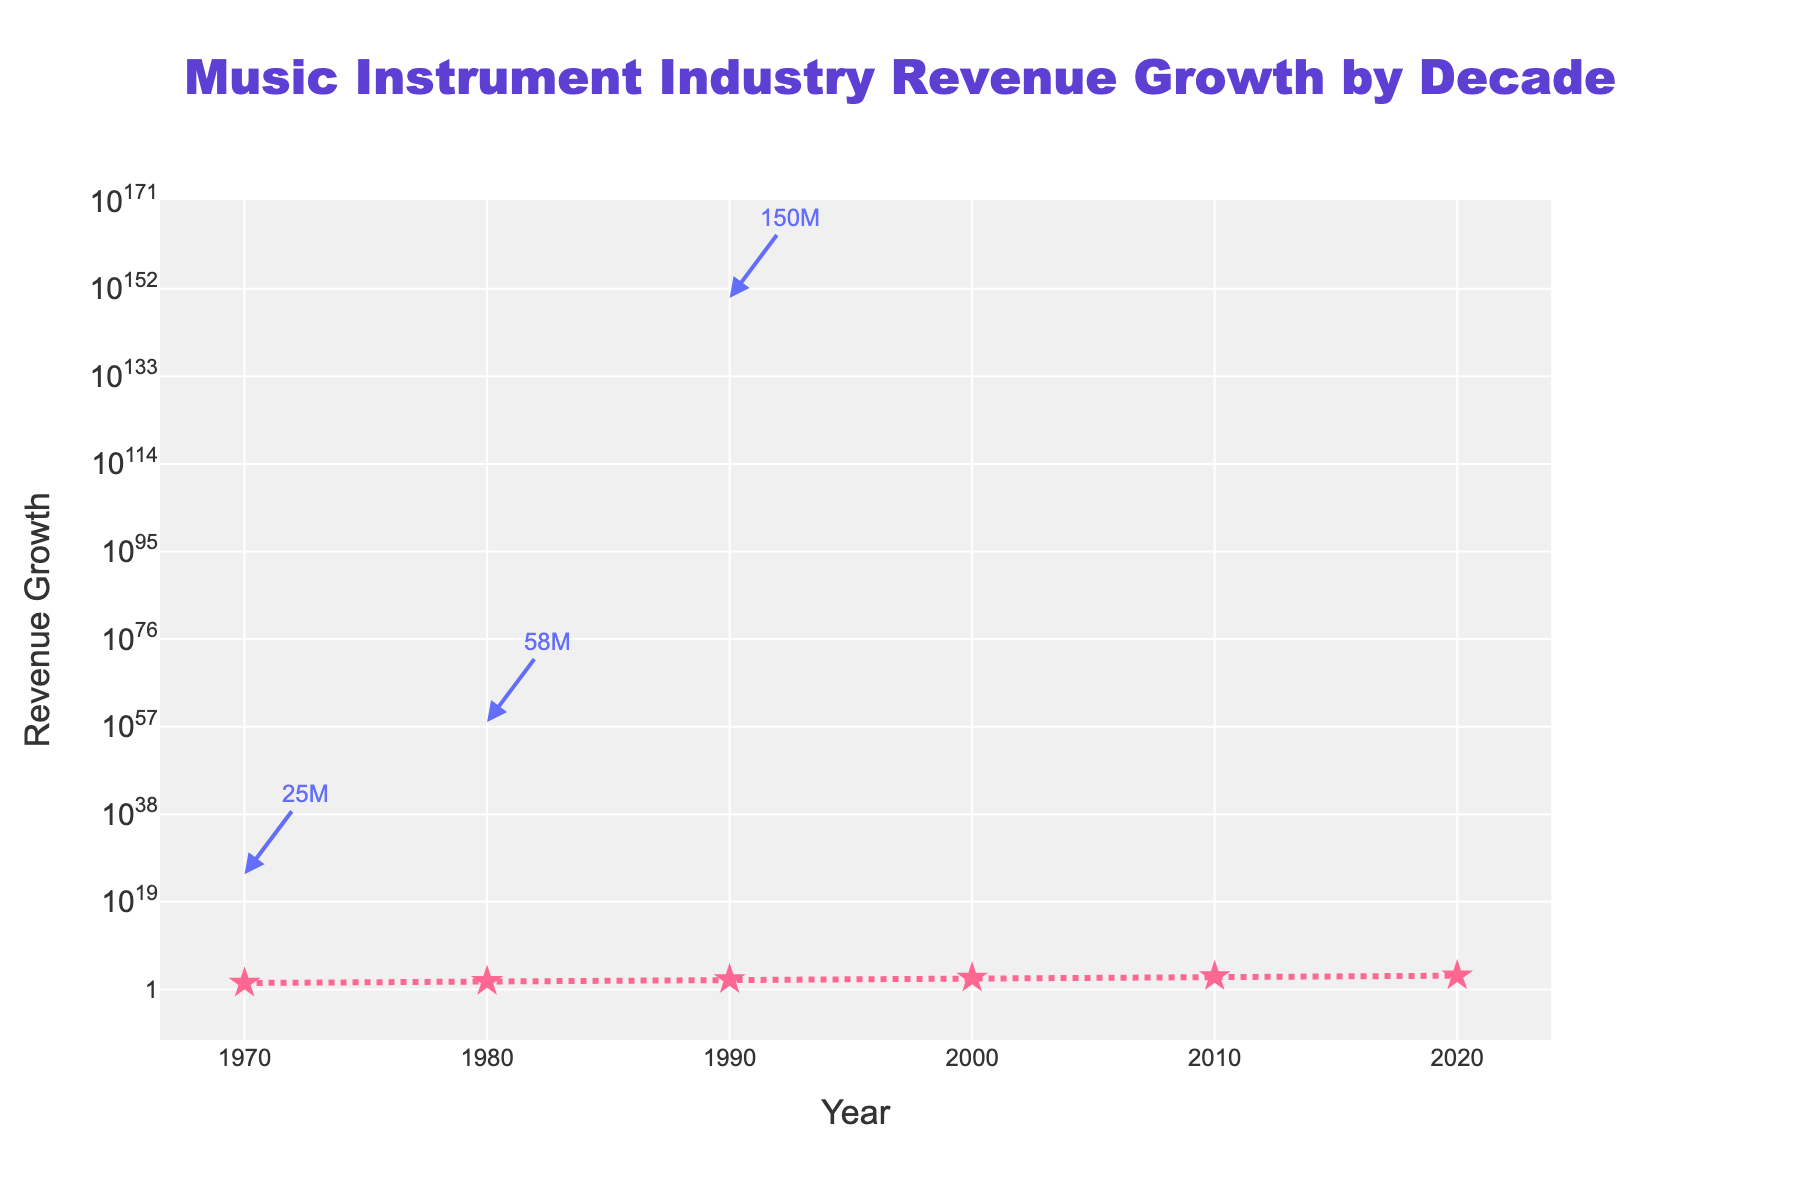What is the title of the figure? The title of the figure is usually at the top center of the visual. Here, it reads "Music Instrument Industry Revenue Growth by Decade."
Answer: Music Instrument Industry Revenue Growth by Decade How many data points are represented in the figure? Count the number of markers or points shown on the line. There are six data points, each representing a decade from 1970 to 2020.
Answer: 6 What kind of trend do you observe from the 1970s to the 2020s in the revenue growth of the music instrument industry? The revenue growth shows an increasing trend over the decades. The data points rise exponentially, indicating significant growth in the music instrument industry revenue each decade.
Answer: Increasing trend Which decade experienced the highest revenue growth? By looking at the highest point on the y-axis, the decade of 2020 shows the highest revenue growth with a value of 980.
Answer: 2020 How does the revenue growth in 2020 compare to that in 1970? Compare the values directly. Revenue growth in 2020 is 980, whereas in 1970, it was 25. Calculate the difference: 980 - 25 = 955. Hence, 2020's revenue growth is 955 units higher than 1970's.
Answer: 955 units higher What is the color of the markers and lines representing the revenue growth data? The markers and lines representing the revenue growth data are primarily pink. The markers are star-shaped, and the line is dashed. The figures need to be checked visually.
Answer: Pink What does the text "690M" associated with the 2010 data point indicate? Each data point has an annotation showing the exact value of revenue growth for that year. The "690M" text near the 2010 data point indicates that the revenue growth in 2010 was 690 million units.
Answer: 690 million units By how much did the revenue grow between 1980 and 1990? Subtract the value in 1980 from the value in 1990 to find the growth: 150 - 58 = 92. The revenue grew by 92 units between these two decades.
Answer: 92 units Which decade experienced the least amount of revenue growth, and what was the value? Look at the data points to find the lowest value. The 1970 decade has the least revenue growth at 25 units.
Answer: 1970, 25 units What is the annotation format used in the figure? Each data point has an annotation that includes the revenue growth value followed by the letter 'M' to denote million. The annotations are placed next to their respective data points and use arrows for pointing. You can see this at various points like "25M", "58M", etc.
Answer: Value followed by 'M' for million 